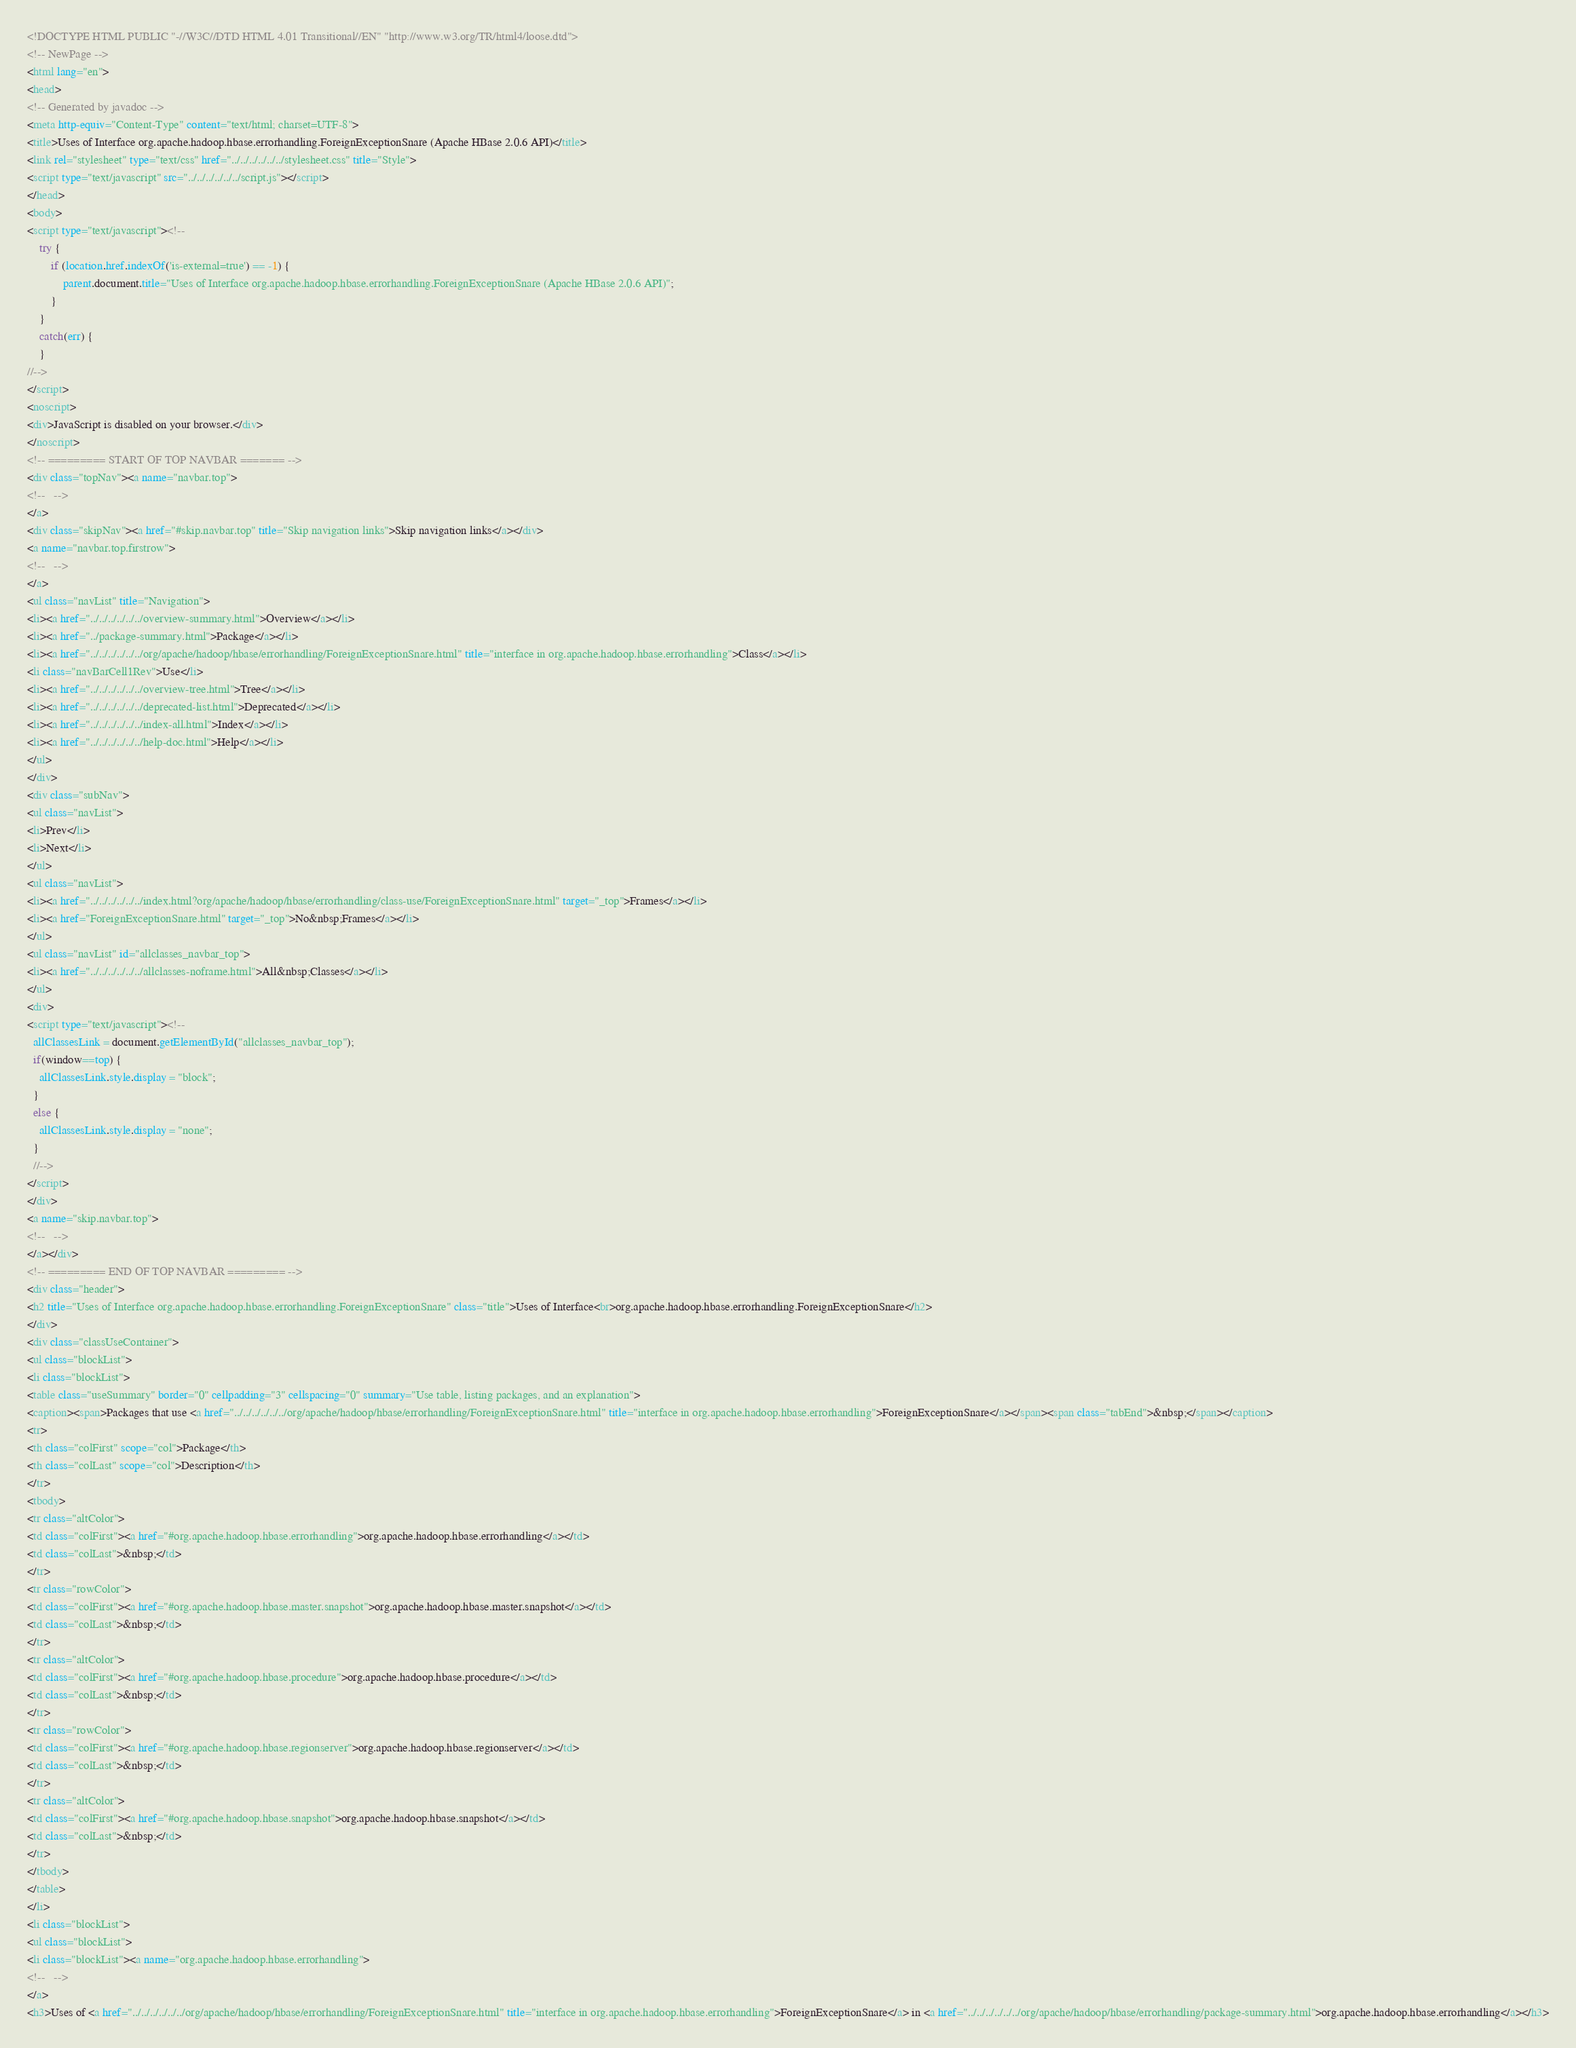<code> <loc_0><loc_0><loc_500><loc_500><_HTML_><!DOCTYPE HTML PUBLIC "-//W3C//DTD HTML 4.01 Transitional//EN" "http://www.w3.org/TR/html4/loose.dtd">
<!-- NewPage -->
<html lang="en">
<head>
<!-- Generated by javadoc -->
<meta http-equiv="Content-Type" content="text/html; charset=UTF-8">
<title>Uses of Interface org.apache.hadoop.hbase.errorhandling.ForeignExceptionSnare (Apache HBase 2.0.6 API)</title>
<link rel="stylesheet" type="text/css" href="../../../../../../stylesheet.css" title="Style">
<script type="text/javascript" src="../../../../../../script.js"></script>
</head>
<body>
<script type="text/javascript"><!--
    try {
        if (location.href.indexOf('is-external=true') == -1) {
            parent.document.title="Uses of Interface org.apache.hadoop.hbase.errorhandling.ForeignExceptionSnare (Apache HBase 2.0.6 API)";
        }
    }
    catch(err) {
    }
//-->
</script>
<noscript>
<div>JavaScript is disabled on your browser.</div>
</noscript>
<!-- ========= START OF TOP NAVBAR ======= -->
<div class="topNav"><a name="navbar.top">
<!--   -->
</a>
<div class="skipNav"><a href="#skip.navbar.top" title="Skip navigation links">Skip navigation links</a></div>
<a name="navbar.top.firstrow">
<!--   -->
</a>
<ul class="navList" title="Navigation">
<li><a href="../../../../../../overview-summary.html">Overview</a></li>
<li><a href="../package-summary.html">Package</a></li>
<li><a href="../../../../../../org/apache/hadoop/hbase/errorhandling/ForeignExceptionSnare.html" title="interface in org.apache.hadoop.hbase.errorhandling">Class</a></li>
<li class="navBarCell1Rev">Use</li>
<li><a href="../../../../../../overview-tree.html">Tree</a></li>
<li><a href="../../../../../../deprecated-list.html">Deprecated</a></li>
<li><a href="../../../../../../index-all.html">Index</a></li>
<li><a href="../../../../../../help-doc.html">Help</a></li>
</ul>
</div>
<div class="subNav">
<ul class="navList">
<li>Prev</li>
<li>Next</li>
</ul>
<ul class="navList">
<li><a href="../../../../../../index.html?org/apache/hadoop/hbase/errorhandling/class-use/ForeignExceptionSnare.html" target="_top">Frames</a></li>
<li><a href="ForeignExceptionSnare.html" target="_top">No&nbsp;Frames</a></li>
</ul>
<ul class="navList" id="allclasses_navbar_top">
<li><a href="../../../../../../allclasses-noframe.html">All&nbsp;Classes</a></li>
</ul>
<div>
<script type="text/javascript"><!--
  allClassesLink = document.getElementById("allclasses_navbar_top");
  if(window==top) {
    allClassesLink.style.display = "block";
  }
  else {
    allClassesLink.style.display = "none";
  }
  //-->
</script>
</div>
<a name="skip.navbar.top">
<!--   -->
</a></div>
<!-- ========= END OF TOP NAVBAR ========= -->
<div class="header">
<h2 title="Uses of Interface org.apache.hadoop.hbase.errorhandling.ForeignExceptionSnare" class="title">Uses of Interface<br>org.apache.hadoop.hbase.errorhandling.ForeignExceptionSnare</h2>
</div>
<div class="classUseContainer">
<ul class="blockList">
<li class="blockList">
<table class="useSummary" border="0" cellpadding="3" cellspacing="0" summary="Use table, listing packages, and an explanation">
<caption><span>Packages that use <a href="../../../../../../org/apache/hadoop/hbase/errorhandling/ForeignExceptionSnare.html" title="interface in org.apache.hadoop.hbase.errorhandling">ForeignExceptionSnare</a></span><span class="tabEnd">&nbsp;</span></caption>
<tr>
<th class="colFirst" scope="col">Package</th>
<th class="colLast" scope="col">Description</th>
</tr>
<tbody>
<tr class="altColor">
<td class="colFirst"><a href="#org.apache.hadoop.hbase.errorhandling">org.apache.hadoop.hbase.errorhandling</a></td>
<td class="colLast">&nbsp;</td>
</tr>
<tr class="rowColor">
<td class="colFirst"><a href="#org.apache.hadoop.hbase.master.snapshot">org.apache.hadoop.hbase.master.snapshot</a></td>
<td class="colLast">&nbsp;</td>
</tr>
<tr class="altColor">
<td class="colFirst"><a href="#org.apache.hadoop.hbase.procedure">org.apache.hadoop.hbase.procedure</a></td>
<td class="colLast">&nbsp;</td>
</tr>
<tr class="rowColor">
<td class="colFirst"><a href="#org.apache.hadoop.hbase.regionserver">org.apache.hadoop.hbase.regionserver</a></td>
<td class="colLast">&nbsp;</td>
</tr>
<tr class="altColor">
<td class="colFirst"><a href="#org.apache.hadoop.hbase.snapshot">org.apache.hadoop.hbase.snapshot</a></td>
<td class="colLast">&nbsp;</td>
</tr>
</tbody>
</table>
</li>
<li class="blockList">
<ul class="blockList">
<li class="blockList"><a name="org.apache.hadoop.hbase.errorhandling">
<!--   -->
</a>
<h3>Uses of <a href="../../../../../../org/apache/hadoop/hbase/errorhandling/ForeignExceptionSnare.html" title="interface in org.apache.hadoop.hbase.errorhandling">ForeignExceptionSnare</a> in <a href="../../../../../../org/apache/hadoop/hbase/errorhandling/package-summary.html">org.apache.hadoop.hbase.errorhandling</a></h3></code> 